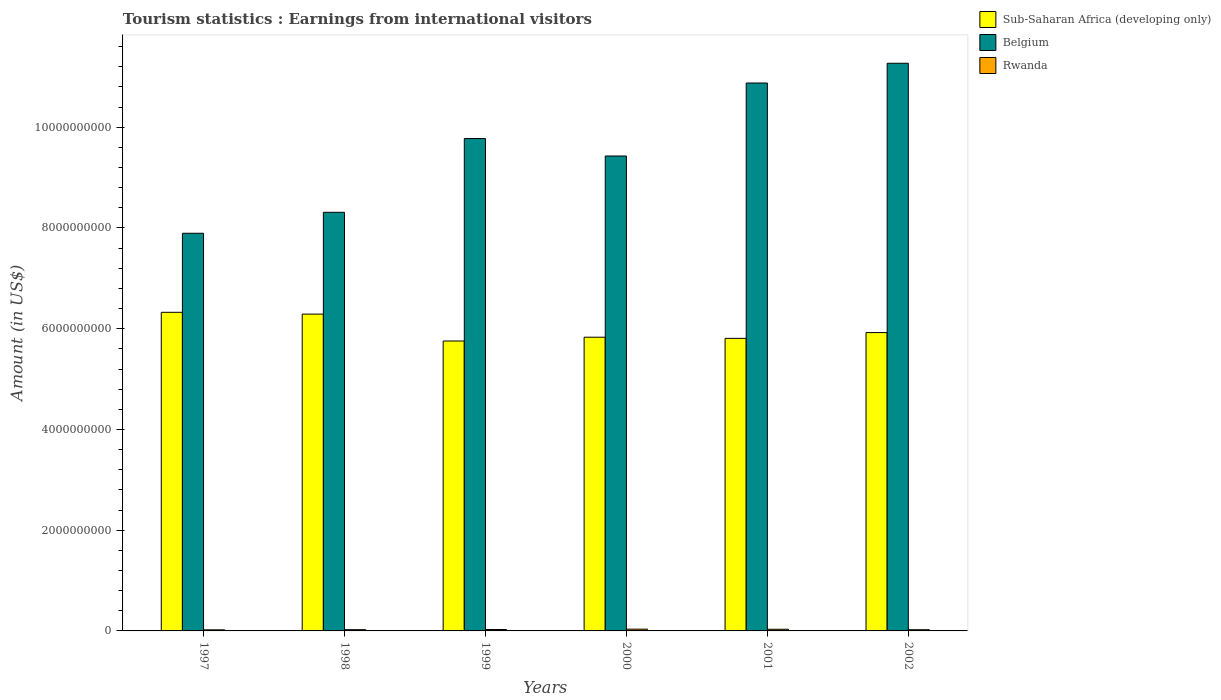How many groups of bars are there?
Offer a very short reply. 6. Are the number of bars per tick equal to the number of legend labels?
Give a very brief answer. Yes. Are the number of bars on each tick of the X-axis equal?
Your answer should be very brief. Yes. What is the label of the 6th group of bars from the left?
Offer a very short reply. 2002. What is the earnings from international visitors in Belgium in 2000?
Make the answer very short. 9.43e+09. Across all years, what is the maximum earnings from international visitors in Belgium?
Your response must be concise. 1.13e+1. Across all years, what is the minimum earnings from international visitors in Rwanda?
Offer a terse response. 2.20e+07. What is the total earnings from international visitors in Sub-Saharan Africa (developing only) in the graph?
Offer a very short reply. 3.59e+1. What is the difference between the earnings from international visitors in Belgium in 1997 and that in 2001?
Your response must be concise. -2.98e+09. What is the difference between the earnings from international visitors in Rwanda in 2000 and the earnings from international visitors in Sub-Saharan Africa (developing only) in 1999?
Provide a succinct answer. -5.72e+09. What is the average earnings from international visitors in Sub-Saharan Africa (developing only) per year?
Ensure brevity in your answer.  5.99e+09. In the year 1997, what is the difference between the earnings from international visitors in Rwanda and earnings from international visitors in Sub-Saharan Africa (developing only)?
Ensure brevity in your answer.  -6.30e+09. In how many years, is the earnings from international visitors in Sub-Saharan Africa (developing only) greater than 9600000000 US$?
Your answer should be compact. 0. What is the ratio of the earnings from international visitors in Belgium in 1999 to that in 2002?
Make the answer very short. 0.87. Is the earnings from international visitors in Sub-Saharan Africa (developing only) in 1999 less than that in 2000?
Ensure brevity in your answer.  Yes. What is the difference between the highest and the second highest earnings from international visitors in Rwanda?
Your response must be concise. 2.00e+06. What is the difference between the highest and the lowest earnings from international visitors in Belgium?
Offer a very short reply. 3.38e+09. Is the sum of the earnings from international visitors in Belgium in 2000 and 2002 greater than the maximum earnings from international visitors in Rwanda across all years?
Your response must be concise. Yes. What does the 1st bar from the left in 2000 represents?
Ensure brevity in your answer.  Sub-Saharan Africa (developing only). What does the 1st bar from the right in 1997 represents?
Ensure brevity in your answer.  Rwanda. Is it the case that in every year, the sum of the earnings from international visitors in Sub-Saharan Africa (developing only) and earnings from international visitors in Rwanda is greater than the earnings from international visitors in Belgium?
Offer a very short reply. No. How many bars are there?
Offer a very short reply. 18. Are all the bars in the graph horizontal?
Offer a very short reply. No. How many years are there in the graph?
Provide a succinct answer. 6. What is the difference between two consecutive major ticks on the Y-axis?
Offer a very short reply. 2.00e+09. Are the values on the major ticks of Y-axis written in scientific E-notation?
Keep it short and to the point. No. Does the graph contain grids?
Provide a succinct answer. No. Where does the legend appear in the graph?
Your answer should be very brief. Top right. How many legend labels are there?
Provide a short and direct response. 3. How are the legend labels stacked?
Keep it short and to the point. Vertical. What is the title of the graph?
Your answer should be compact. Tourism statistics : Earnings from international visitors. What is the label or title of the X-axis?
Give a very brief answer. Years. What is the Amount (in US$) in Sub-Saharan Africa (developing only) in 1997?
Give a very brief answer. 6.33e+09. What is the Amount (in US$) in Belgium in 1997?
Your response must be concise. 7.90e+09. What is the Amount (in US$) of Rwanda in 1997?
Provide a short and direct response. 2.20e+07. What is the Amount (in US$) in Sub-Saharan Africa (developing only) in 1998?
Make the answer very short. 6.29e+09. What is the Amount (in US$) of Belgium in 1998?
Make the answer very short. 8.31e+09. What is the Amount (in US$) of Rwanda in 1998?
Give a very brief answer. 2.50e+07. What is the Amount (in US$) in Sub-Saharan Africa (developing only) in 1999?
Your answer should be very brief. 5.76e+09. What is the Amount (in US$) of Belgium in 1999?
Offer a terse response. 9.78e+09. What is the Amount (in US$) of Rwanda in 1999?
Your answer should be very brief. 2.80e+07. What is the Amount (in US$) in Sub-Saharan Africa (developing only) in 2000?
Offer a very short reply. 5.83e+09. What is the Amount (in US$) in Belgium in 2000?
Ensure brevity in your answer.  9.43e+09. What is the Amount (in US$) of Rwanda in 2000?
Give a very brief answer. 3.50e+07. What is the Amount (in US$) in Sub-Saharan Africa (developing only) in 2001?
Offer a terse response. 5.81e+09. What is the Amount (in US$) in Belgium in 2001?
Provide a short and direct response. 1.09e+1. What is the Amount (in US$) of Rwanda in 2001?
Provide a succinct answer. 3.30e+07. What is the Amount (in US$) of Sub-Saharan Africa (developing only) in 2002?
Provide a succinct answer. 5.92e+09. What is the Amount (in US$) of Belgium in 2002?
Provide a succinct answer. 1.13e+1. What is the Amount (in US$) in Rwanda in 2002?
Offer a terse response. 2.40e+07. Across all years, what is the maximum Amount (in US$) of Sub-Saharan Africa (developing only)?
Provide a short and direct response. 6.33e+09. Across all years, what is the maximum Amount (in US$) in Belgium?
Give a very brief answer. 1.13e+1. Across all years, what is the maximum Amount (in US$) in Rwanda?
Your answer should be compact. 3.50e+07. Across all years, what is the minimum Amount (in US$) in Sub-Saharan Africa (developing only)?
Keep it short and to the point. 5.76e+09. Across all years, what is the minimum Amount (in US$) in Belgium?
Give a very brief answer. 7.90e+09. Across all years, what is the minimum Amount (in US$) of Rwanda?
Your response must be concise. 2.20e+07. What is the total Amount (in US$) in Sub-Saharan Africa (developing only) in the graph?
Your answer should be very brief. 3.59e+1. What is the total Amount (in US$) in Belgium in the graph?
Give a very brief answer. 5.76e+1. What is the total Amount (in US$) in Rwanda in the graph?
Your answer should be compact. 1.67e+08. What is the difference between the Amount (in US$) of Sub-Saharan Africa (developing only) in 1997 and that in 1998?
Make the answer very short. 3.57e+07. What is the difference between the Amount (in US$) of Belgium in 1997 and that in 1998?
Your answer should be very brief. -4.16e+08. What is the difference between the Amount (in US$) of Rwanda in 1997 and that in 1998?
Your answer should be compact. -3.00e+06. What is the difference between the Amount (in US$) of Sub-Saharan Africa (developing only) in 1997 and that in 1999?
Provide a short and direct response. 5.70e+08. What is the difference between the Amount (in US$) in Belgium in 1997 and that in 1999?
Your answer should be very brief. -1.88e+09. What is the difference between the Amount (in US$) in Rwanda in 1997 and that in 1999?
Offer a very short reply. -6.00e+06. What is the difference between the Amount (in US$) of Sub-Saharan Africa (developing only) in 1997 and that in 2000?
Give a very brief answer. 4.95e+08. What is the difference between the Amount (in US$) in Belgium in 1997 and that in 2000?
Ensure brevity in your answer.  -1.53e+09. What is the difference between the Amount (in US$) of Rwanda in 1997 and that in 2000?
Your response must be concise. -1.30e+07. What is the difference between the Amount (in US$) in Sub-Saharan Africa (developing only) in 1997 and that in 2001?
Make the answer very short. 5.18e+08. What is the difference between the Amount (in US$) in Belgium in 1997 and that in 2001?
Ensure brevity in your answer.  -2.98e+09. What is the difference between the Amount (in US$) of Rwanda in 1997 and that in 2001?
Your answer should be compact. -1.10e+07. What is the difference between the Amount (in US$) in Sub-Saharan Africa (developing only) in 1997 and that in 2002?
Ensure brevity in your answer.  4.03e+08. What is the difference between the Amount (in US$) in Belgium in 1997 and that in 2002?
Your answer should be very brief. -3.38e+09. What is the difference between the Amount (in US$) in Rwanda in 1997 and that in 2002?
Ensure brevity in your answer.  -2.00e+06. What is the difference between the Amount (in US$) of Sub-Saharan Africa (developing only) in 1998 and that in 1999?
Your answer should be very brief. 5.34e+08. What is the difference between the Amount (in US$) in Belgium in 1998 and that in 1999?
Provide a succinct answer. -1.46e+09. What is the difference between the Amount (in US$) of Sub-Saharan Africa (developing only) in 1998 and that in 2000?
Your response must be concise. 4.59e+08. What is the difference between the Amount (in US$) in Belgium in 1998 and that in 2000?
Give a very brief answer. -1.12e+09. What is the difference between the Amount (in US$) of Rwanda in 1998 and that in 2000?
Offer a terse response. -1.00e+07. What is the difference between the Amount (in US$) in Sub-Saharan Africa (developing only) in 1998 and that in 2001?
Ensure brevity in your answer.  4.82e+08. What is the difference between the Amount (in US$) of Belgium in 1998 and that in 2001?
Provide a succinct answer. -2.57e+09. What is the difference between the Amount (in US$) of Rwanda in 1998 and that in 2001?
Provide a succinct answer. -8.00e+06. What is the difference between the Amount (in US$) of Sub-Saharan Africa (developing only) in 1998 and that in 2002?
Ensure brevity in your answer.  3.67e+08. What is the difference between the Amount (in US$) in Belgium in 1998 and that in 2002?
Your answer should be very brief. -2.96e+09. What is the difference between the Amount (in US$) in Sub-Saharan Africa (developing only) in 1999 and that in 2000?
Give a very brief answer. -7.52e+07. What is the difference between the Amount (in US$) of Belgium in 1999 and that in 2000?
Your answer should be very brief. 3.46e+08. What is the difference between the Amount (in US$) in Rwanda in 1999 and that in 2000?
Give a very brief answer. -7.00e+06. What is the difference between the Amount (in US$) of Sub-Saharan Africa (developing only) in 1999 and that in 2001?
Offer a terse response. -5.22e+07. What is the difference between the Amount (in US$) of Belgium in 1999 and that in 2001?
Provide a succinct answer. -1.10e+09. What is the difference between the Amount (in US$) in Rwanda in 1999 and that in 2001?
Provide a short and direct response. -5.00e+06. What is the difference between the Amount (in US$) of Sub-Saharan Africa (developing only) in 1999 and that in 2002?
Give a very brief answer. -1.67e+08. What is the difference between the Amount (in US$) of Belgium in 1999 and that in 2002?
Offer a terse response. -1.50e+09. What is the difference between the Amount (in US$) in Rwanda in 1999 and that in 2002?
Keep it short and to the point. 4.00e+06. What is the difference between the Amount (in US$) in Sub-Saharan Africa (developing only) in 2000 and that in 2001?
Your answer should be compact. 2.30e+07. What is the difference between the Amount (in US$) of Belgium in 2000 and that in 2001?
Provide a short and direct response. -1.45e+09. What is the difference between the Amount (in US$) of Sub-Saharan Africa (developing only) in 2000 and that in 2002?
Your answer should be compact. -9.17e+07. What is the difference between the Amount (in US$) in Belgium in 2000 and that in 2002?
Your answer should be very brief. -1.84e+09. What is the difference between the Amount (in US$) in Rwanda in 2000 and that in 2002?
Give a very brief answer. 1.10e+07. What is the difference between the Amount (in US$) in Sub-Saharan Africa (developing only) in 2001 and that in 2002?
Your answer should be compact. -1.15e+08. What is the difference between the Amount (in US$) in Belgium in 2001 and that in 2002?
Keep it short and to the point. -3.92e+08. What is the difference between the Amount (in US$) of Rwanda in 2001 and that in 2002?
Provide a short and direct response. 9.00e+06. What is the difference between the Amount (in US$) of Sub-Saharan Africa (developing only) in 1997 and the Amount (in US$) of Belgium in 1998?
Your answer should be compact. -1.99e+09. What is the difference between the Amount (in US$) in Sub-Saharan Africa (developing only) in 1997 and the Amount (in US$) in Rwanda in 1998?
Offer a very short reply. 6.30e+09. What is the difference between the Amount (in US$) of Belgium in 1997 and the Amount (in US$) of Rwanda in 1998?
Ensure brevity in your answer.  7.87e+09. What is the difference between the Amount (in US$) in Sub-Saharan Africa (developing only) in 1997 and the Amount (in US$) in Belgium in 1999?
Offer a very short reply. -3.45e+09. What is the difference between the Amount (in US$) in Sub-Saharan Africa (developing only) in 1997 and the Amount (in US$) in Rwanda in 1999?
Your response must be concise. 6.30e+09. What is the difference between the Amount (in US$) of Belgium in 1997 and the Amount (in US$) of Rwanda in 1999?
Your answer should be very brief. 7.87e+09. What is the difference between the Amount (in US$) of Sub-Saharan Africa (developing only) in 1997 and the Amount (in US$) of Belgium in 2000?
Give a very brief answer. -3.10e+09. What is the difference between the Amount (in US$) of Sub-Saharan Africa (developing only) in 1997 and the Amount (in US$) of Rwanda in 2000?
Keep it short and to the point. 6.29e+09. What is the difference between the Amount (in US$) of Belgium in 1997 and the Amount (in US$) of Rwanda in 2000?
Ensure brevity in your answer.  7.86e+09. What is the difference between the Amount (in US$) of Sub-Saharan Africa (developing only) in 1997 and the Amount (in US$) of Belgium in 2001?
Offer a terse response. -4.55e+09. What is the difference between the Amount (in US$) of Sub-Saharan Africa (developing only) in 1997 and the Amount (in US$) of Rwanda in 2001?
Offer a terse response. 6.29e+09. What is the difference between the Amount (in US$) in Belgium in 1997 and the Amount (in US$) in Rwanda in 2001?
Offer a very short reply. 7.86e+09. What is the difference between the Amount (in US$) of Sub-Saharan Africa (developing only) in 1997 and the Amount (in US$) of Belgium in 2002?
Keep it short and to the point. -4.94e+09. What is the difference between the Amount (in US$) of Sub-Saharan Africa (developing only) in 1997 and the Amount (in US$) of Rwanda in 2002?
Your response must be concise. 6.30e+09. What is the difference between the Amount (in US$) in Belgium in 1997 and the Amount (in US$) in Rwanda in 2002?
Keep it short and to the point. 7.87e+09. What is the difference between the Amount (in US$) in Sub-Saharan Africa (developing only) in 1998 and the Amount (in US$) in Belgium in 1999?
Ensure brevity in your answer.  -3.49e+09. What is the difference between the Amount (in US$) in Sub-Saharan Africa (developing only) in 1998 and the Amount (in US$) in Rwanda in 1999?
Provide a short and direct response. 6.26e+09. What is the difference between the Amount (in US$) of Belgium in 1998 and the Amount (in US$) of Rwanda in 1999?
Ensure brevity in your answer.  8.28e+09. What is the difference between the Amount (in US$) in Sub-Saharan Africa (developing only) in 1998 and the Amount (in US$) in Belgium in 2000?
Offer a very short reply. -3.14e+09. What is the difference between the Amount (in US$) of Sub-Saharan Africa (developing only) in 1998 and the Amount (in US$) of Rwanda in 2000?
Provide a succinct answer. 6.25e+09. What is the difference between the Amount (in US$) of Belgium in 1998 and the Amount (in US$) of Rwanda in 2000?
Your response must be concise. 8.28e+09. What is the difference between the Amount (in US$) in Sub-Saharan Africa (developing only) in 1998 and the Amount (in US$) in Belgium in 2001?
Give a very brief answer. -4.59e+09. What is the difference between the Amount (in US$) in Sub-Saharan Africa (developing only) in 1998 and the Amount (in US$) in Rwanda in 2001?
Provide a succinct answer. 6.26e+09. What is the difference between the Amount (in US$) of Belgium in 1998 and the Amount (in US$) of Rwanda in 2001?
Offer a terse response. 8.28e+09. What is the difference between the Amount (in US$) in Sub-Saharan Africa (developing only) in 1998 and the Amount (in US$) in Belgium in 2002?
Your answer should be very brief. -4.98e+09. What is the difference between the Amount (in US$) in Sub-Saharan Africa (developing only) in 1998 and the Amount (in US$) in Rwanda in 2002?
Your answer should be very brief. 6.27e+09. What is the difference between the Amount (in US$) of Belgium in 1998 and the Amount (in US$) of Rwanda in 2002?
Offer a terse response. 8.29e+09. What is the difference between the Amount (in US$) in Sub-Saharan Africa (developing only) in 1999 and the Amount (in US$) in Belgium in 2000?
Offer a very short reply. -3.67e+09. What is the difference between the Amount (in US$) of Sub-Saharan Africa (developing only) in 1999 and the Amount (in US$) of Rwanda in 2000?
Make the answer very short. 5.72e+09. What is the difference between the Amount (in US$) of Belgium in 1999 and the Amount (in US$) of Rwanda in 2000?
Provide a short and direct response. 9.74e+09. What is the difference between the Amount (in US$) in Sub-Saharan Africa (developing only) in 1999 and the Amount (in US$) in Belgium in 2001?
Provide a short and direct response. -5.12e+09. What is the difference between the Amount (in US$) of Sub-Saharan Africa (developing only) in 1999 and the Amount (in US$) of Rwanda in 2001?
Your answer should be very brief. 5.72e+09. What is the difference between the Amount (in US$) of Belgium in 1999 and the Amount (in US$) of Rwanda in 2001?
Give a very brief answer. 9.74e+09. What is the difference between the Amount (in US$) of Sub-Saharan Africa (developing only) in 1999 and the Amount (in US$) of Belgium in 2002?
Offer a terse response. -5.51e+09. What is the difference between the Amount (in US$) of Sub-Saharan Africa (developing only) in 1999 and the Amount (in US$) of Rwanda in 2002?
Provide a short and direct response. 5.73e+09. What is the difference between the Amount (in US$) in Belgium in 1999 and the Amount (in US$) in Rwanda in 2002?
Keep it short and to the point. 9.75e+09. What is the difference between the Amount (in US$) in Sub-Saharan Africa (developing only) in 2000 and the Amount (in US$) in Belgium in 2001?
Offer a terse response. -5.05e+09. What is the difference between the Amount (in US$) in Sub-Saharan Africa (developing only) in 2000 and the Amount (in US$) in Rwanda in 2001?
Your answer should be compact. 5.80e+09. What is the difference between the Amount (in US$) of Belgium in 2000 and the Amount (in US$) of Rwanda in 2001?
Provide a succinct answer. 9.40e+09. What is the difference between the Amount (in US$) in Sub-Saharan Africa (developing only) in 2000 and the Amount (in US$) in Belgium in 2002?
Offer a very short reply. -5.44e+09. What is the difference between the Amount (in US$) of Sub-Saharan Africa (developing only) in 2000 and the Amount (in US$) of Rwanda in 2002?
Make the answer very short. 5.81e+09. What is the difference between the Amount (in US$) of Belgium in 2000 and the Amount (in US$) of Rwanda in 2002?
Your answer should be compact. 9.40e+09. What is the difference between the Amount (in US$) of Sub-Saharan Africa (developing only) in 2001 and the Amount (in US$) of Belgium in 2002?
Offer a very short reply. -5.46e+09. What is the difference between the Amount (in US$) of Sub-Saharan Africa (developing only) in 2001 and the Amount (in US$) of Rwanda in 2002?
Your answer should be compact. 5.78e+09. What is the difference between the Amount (in US$) in Belgium in 2001 and the Amount (in US$) in Rwanda in 2002?
Keep it short and to the point. 1.09e+1. What is the average Amount (in US$) in Sub-Saharan Africa (developing only) per year?
Provide a succinct answer. 5.99e+09. What is the average Amount (in US$) of Belgium per year?
Your answer should be very brief. 9.59e+09. What is the average Amount (in US$) in Rwanda per year?
Make the answer very short. 2.78e+07. In the year 1997, what is the difference between the Amount (in US$) of Sub-Saharan Africa (developing only) and Amount (in US$) of Belgium?
Your response must be concise. -1.57e+09. In the year 1997, what is the difference between the Amount (in US$) in Sub-Saharan Africa (developing only) and Amount (in US$) in Rwanda?
Offer a terse response. 6.30e+09. In the year 1997, what is the difference between the Amount (in US$) of Belgium and Amount (in US$) of Rwanda?
Provide a short and direct response. 7.87e+09. In the year 1998, what is the difference between the Amount (in US$) of Sub-Saharan Africa (developing only) and Amount (in US$) of Belgium?
Provide a succinct answer. -2.02e+09. In the year 1998, what is the difference between the Amount (in US$) of Sub-Saharan Africa (developing only) and Amount (in US$) of Rwanda?
Provide a succinct answer. 6.26e+09. In the year 1998, what is the difference between the Amount (in US$) of Belgium and Amount (in US$) of Rwanda?
Provide a succinct answer. 8.29e+09. In the year 1999, what is the difference between the Amount (in US$) in Sub-Saharan Africa (developing only) and Amount (in US$) in Belgium?
Your answer should be compact. -4.02e+09. In the year 1999, what is the difference between the Amount (in US$) in Sub-Saharan Africa (developing only) and Amount (in US$) in Rwanda?
Your answer should be very brief. 5.73e+09. In the year 1999, what is the difference between the Amount (in US$) in Belgium and Amount (in US$) in Rwanda?
Your response must be concise. 9.75e+09. In the year 2000, what is the difference between the Amount (in US$) in Sub-Saharan Africa (developing only) and Amount (in US$) in Belgium?
Offer a very short reply. -3.60e+09. In the year 2000, what is the difference between the Amount (in US$) in Sub-Saharan Africa (developing only) and Amount (in US$) in Rwanda?
Make the answer very short. 5.80e+09. In the year 2000, what is the difference between the Amount (in US$) in Belgium and Amount (in US$) in Rwanda?
Provide a short and direct response. 9.39e+09. In the year 2001, what is the difference between the Amount (in US$) of Sub-Saharan Africa (developing only) and Amount (in US$) of Belgium?
Provide a short and direct response. -5.07e+09. In the year 2001, what is the difference between the Amount (in US$) in Sub-Saharan Africa (developing only) and Amount (in US$) in Rwanda?
Your answer should be very brief. 5.78e+09. In the year 2001, what is the difference between the Amount (in US$) of Belgium and Amount (in US$) of Rwanda?
Give a very brief answer. 1.08e+1. In the year 2002, what is the difference between the Amount (in US$) in Sub-Saharan Africa (developing only) and Amount (in US$) in Belgium?
Your response must be concise. -5.35e+09. In the year 2002, what is the difference between the Amount (in US$) in Sub-Saharan Africa (developing only) and Amount (in US$) in Rwanda?
Keep it short and to the point. 5.90e+09. In the year 2002, what is the difference between the Amount (in US$) of Belgium and Amount (in US$) of Rwanda?
Offer a terse response. 1.12e+1. What is the ratio of the Amount (in US$) of Sub-Saharan Africa (developing only) in 1997 to that in 1998?
Ensure brevity in your answer.  1.01. What is the ratio of the Amount (in US$) of Belgium in 1997 to that in 1998?
Provide a succinct answer. 0.95. What is the ratio of the Amount (in US$) in Rwanda in 1997 to that in 1998?
Make the answer very short. 0.88. What is the ratio of the Amount (in US$) of Sub-Saharan Africa (developing only) in 1997 to that in 1999?
Provide a succinct answer. 1.1. What is the ratio of the Amount (in US$) in Belgium in 1997 to that in 1999?
Your answer should be compact. 0.81. What is the ratio of the Amount (in US$) in Rwanda in 1997 to that in 1999?
Give a very brief answer. 0.79. What is the ratio of the Amount (in US$) in Sub-Saharan Africa (developing only) in 1997 to that in 2000?
Keep it short and to the point. 1.08. What is the ratio of the Amount (in US$) in Belgium in 1997 to that in 2000?
Your response must be concise. 0.84. What is the ratio of the Amount (in US$) of Rwanda in 1997 to that in 2000?
Your response must be concise. 0.63. What is the ratio of the Amount (in US$) in Sub-Saharan Africa (developing only) in 1997 to that in 2001?
Give a very brief answer. 1.09. What is the ratio of the Amount (in US$) in Belgium in 1997 to that in 2001?
Offer a very short reply. 0.73. What is the ratio of the Amount (in US$) of Rwanda in 1997 to that in 2001?
Offer a very short reply. 0.67. What is the ratio of the Amount (in US$) of Sub-Saharan Africa (developing only) in 1997 to that in 2002?
Make the answer very short. 1.07. What is the ratio of the Amount (in US$) of Belgium in 1997 to that in 2002?
Provide a short and direct response. 0.7. What is the ratio of the Amount (in US$) of Sub-Saharan Africa (developing only) in 1998 to that in 1999?
Your answer should be compact. 1.09. What is the ratio of the Amount (in US$) of Belgium in 1998 to that in 1999?
Your response must be concise. 0.85. What is the ratio of the Amount (in US$) of Rwanda in 1998 to that in 1999?
Make the answer very short. 0.89. What is the ratio of the Amount (in US$) of Sub-Saharan Africa (developing only) in 1998 to that in 2000?
Provide a succinct answer. 1.08. What is the ratio of the Amount (in US$) in Belgium in 1998 to that in 2000?
Keep it short and to the point. 0.88. What is the ratio of the Amount (in US$) of Sub-Saharan Africa (developing only) in 1998 to that in 2001?
Make the answer very short. 1.08. What is the ratio of the Amount (in US$) of Belgium in 1998 to that in 2001?
Your answer should be very brief. 0.76. What is the ratio of the Amount (in US$) of Rwanda in 1998 to that in 2001?
Offer a terse response. 0.76. What is the ratio of the Amount (in US$) in Sub-Saharan Africa (developing only) in 1998 to that in 2002?
Keep it short and to the point. 1.06. What is the ratio of the Amount (in US$) of Belgium in 1998 to that in 2002?
Your answer should be compact. 0.74. What is the ratio of the Amount (in US$) in Rwanda in 1998 to that in 2002?
Give a very brief answer. 1.04. What is the ratio of the Amount (in US$) in Sub-Saharan Africa (developing only) in 1999 to that in 2000?
Your answer should be compact. 0.99. What is the ratio of the Amount (in US$) in Belgium in 1999 to that in 2000?
Offer a terse response. 1.04. What is the ratio of the Amount (in US$) of Belgium in 1999 to that in 2001?
Offer a terse response. 0.9. What is the ratio of the Amount (in US$) of Rwanda in 1999 to that in 2001?
Make the answer very short. 0.85. What is the ratio of the Amount (in US$) of Sub-Saharan Africa (developing only) in 1999 to that in 2002?
Give a very brief answer. 0.97. What is the ratio of the Amount (in US$) of Belgium in 1999 to that in 2002?
Your answer should be very brief. 0.87. What is the ratio of the Amount (in US$) of Rwanda in 1999 to that in 2002?
Provide a short and direct response. 1.17. What is the ratio of the Amount (in US$) of Sub-Saharan Africa (developing only) in 2000 to that in 2001?
Ensure brevity in your answer.  1. What is the ratio of the Amount (in US$) of Belgium in 2000 to that in 2001?
Ensure brevity in your answer.  0.87. What is the ratio of the Amount (in US$) of Rwanda in 2000 to that in 2001?
Your answer should be very brief. 1.06. What is the ratio of the Amount (in US$) in Sub-Saharan Africa (developing only) in 2000 to that in 2002?
Offer a very short reply. 0.98. What is the ratio of the Amount (in US$) in Belgium in 2000 to that in 2002?
Provide a short and direct response. 0.84. What is the ratio of the Amount (in US$) in Rwanda in 2000 to that in 2002?
Offer a terse response. 1.46. What is the ratio of the Amount (in US$) in Sub-Saharan Africa (developing only) in 2001 to that in 2002?
Your answer should be very brief. 0.98. What is the ratio of the Amount (in US$) in Belgium in 2001 to that in 2002?
Ensure brevity in your answer.  0.97. What is the ratio of the Amount (in US$) in Rwanda in 2001 to that in 2002?
Offer a very short reply. 1.38. What is the difference between the highest and the second highest Amount (in US$) in Sub-Saharan Africa (developing only)?
Make the answer very short. 3.57e+07. What is the difference between the highest and the second highest Amount (in US$) of Belgium?
Offer a very short reply. 3.92e+08. What is the difference between the highest and the lowest Amount (in US$) of Sub-Saharan Africa (developing only)?
Offer a very short reply. 5.70e+08. What is the difference between the highest and the lowest Amount (in US$) in Belgium?
Your answer should be compact. 3.38e+09. What is the difference between the highest and the lowest Amount (in US$) of Rwanda?
Give a very brief answer. 1.30e+07. 